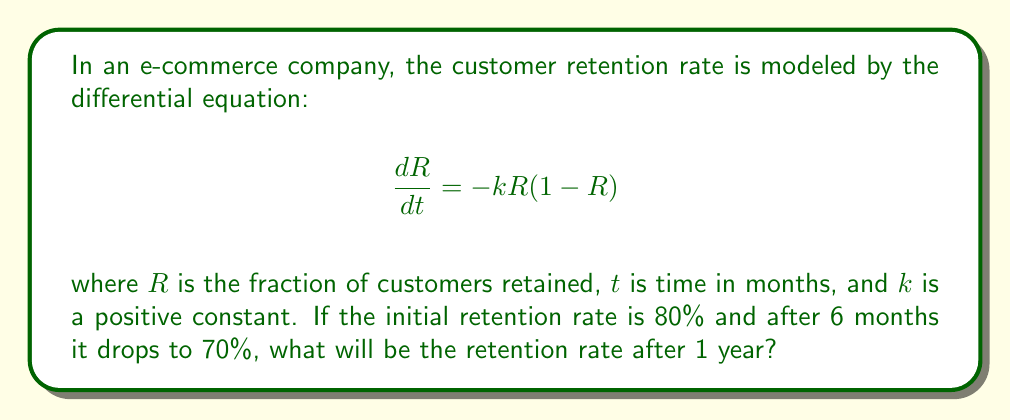Could you help me with this problem? To solve this problem, we need to follow these steps:

1) First, we need to solve the differential equation. This is a separable equation:

   $$\frac{dR}{R(1-R)} = -k dt$$

2) Integrating both sides:

   $$\int \frac{dR}{R(1-R)} = -k \int dt$$

3) The left side can be integrated using partial fractions:

   $$\ln(\frac{R}{1-R}) = -kt + C$$

4) Solving for R:

   $$R = \frac{1}{1 + Ae^{kt}}$$

   where $A = e^{-C}$

5) Now we can use the initial condition: $R(0) = 0.8$

   $$0.8 = \frac{1}{1 + A}$$
   $$A = 0.25$$

6) We can find $k$ using the condition that $R(6) = 0.7$:

   $$0.7 = \frac{1}{1 + 0.25e^{6k}}$$

   Solving this:

   $$k \approx 0.0431$$

7) Now we can find $R(12)$:

   $$R(12) = \frac{1}{1 + 0.25e^{12 \cdot 0.0431}}$$

8) Calculating this value:

   $$R(12) \approx 0.6177$$

Therefore, after 1 year (12 months), the retention rate will be approximately 61.77%.
Answer: 61.77% 